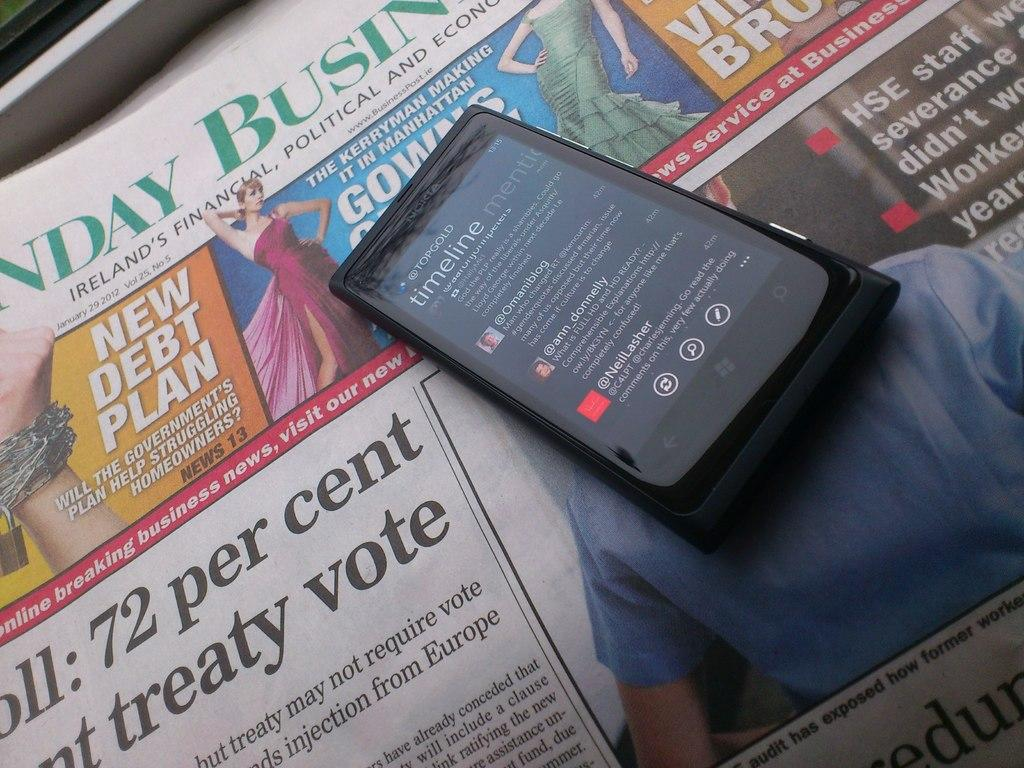<image>
Write a terse but informative summary of the picture. Black Nokia phone with a  twitter page pulled up of Top Gold. 